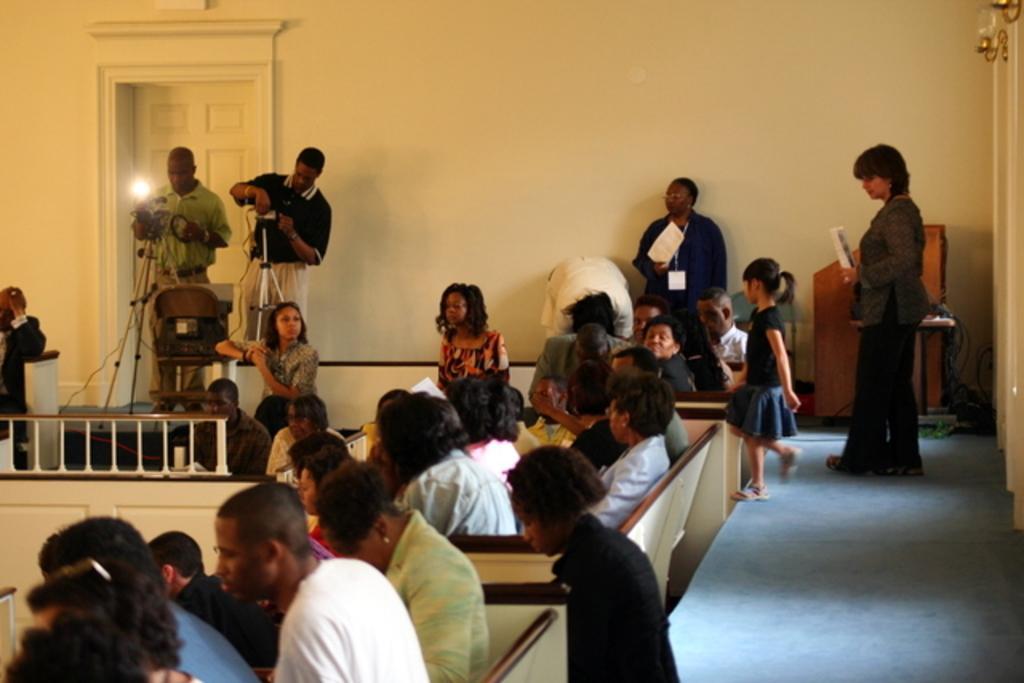Can you describe this image briefly? In this image there are a few people sitting on sofas, in the background there are a few people standing and there are two stands, on that there are cameras and a light and there is a wall, for that wall there is a door, on the right there is a podium and a path. 